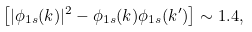Convert formula to latex. <formula><loc_0><loc_0><loc_500><loc_500>\left [ | \phi _ { 1 s } ( k ) | ^ { 2 } - \phi _ { 1 s } ( k ) \phi _ { 1 s } ( k ^ { \prime } ) \right ] \sim 1 . 4 ,</formula> 